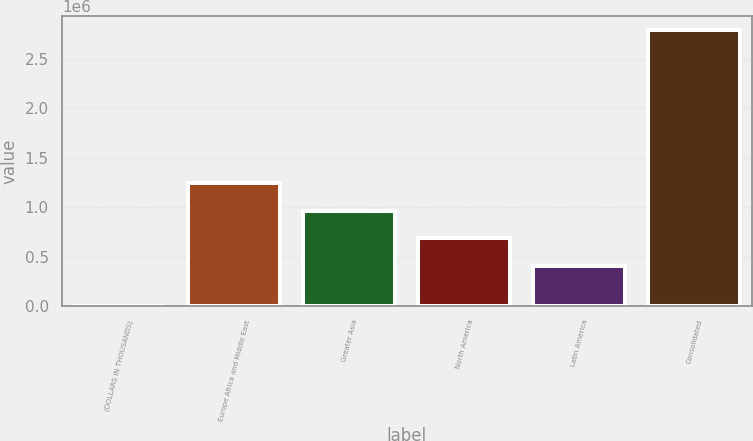<chart> <loc_0><loc_0><loc_500><loc_500><bar_chart><fcel>(DOLLARS IN THOUSANDS)<fcel>Europe Africa and Middle East<fcel>Greater Asia<fcel>North America<fcel>Latin America<fcel>Consolidated<nl><fcel>2011<fcel>1.24327e+06<fcel>964669<fcel>686069<fcel>407468<fcel>2.78802e+06<nl></chart> 